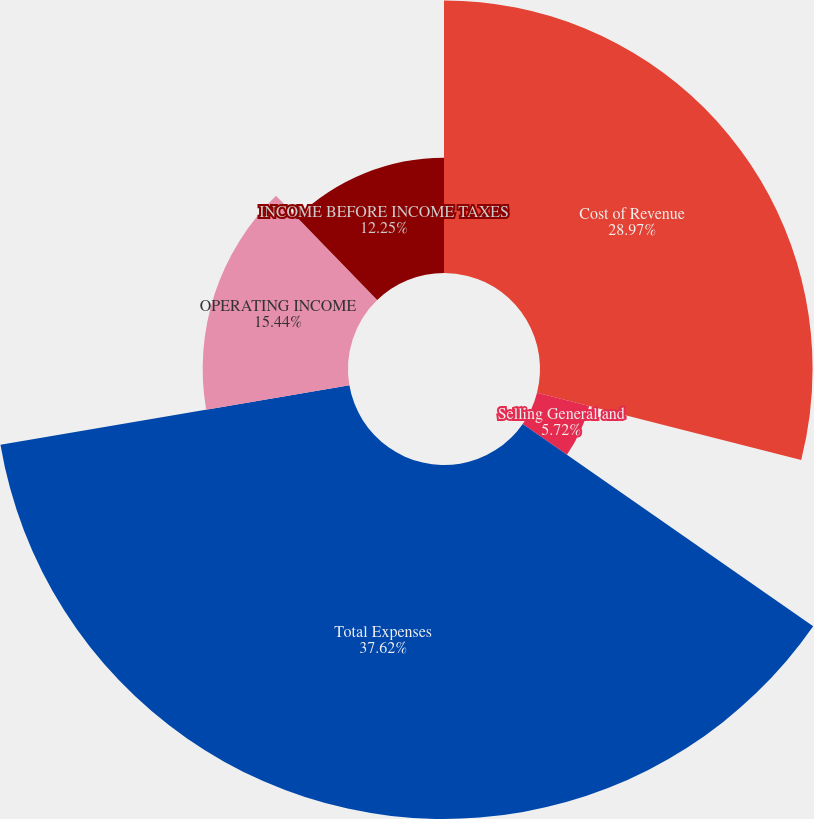Convert chart. <chart><loc_0><loc_0><loc_500><loc_500><pie_chart><fcel>Cost of Revenue<fcel>Selling General and<fcel>Total Expenses<fcel>OPERATING INCOME<fcel>INCOME BEFORE INCOME TAXES<nl><fcel>28.96%<fcel>5.72%<fcel>37.61%<fcel>15.44%<fcel>12.25%<nl></chart> 